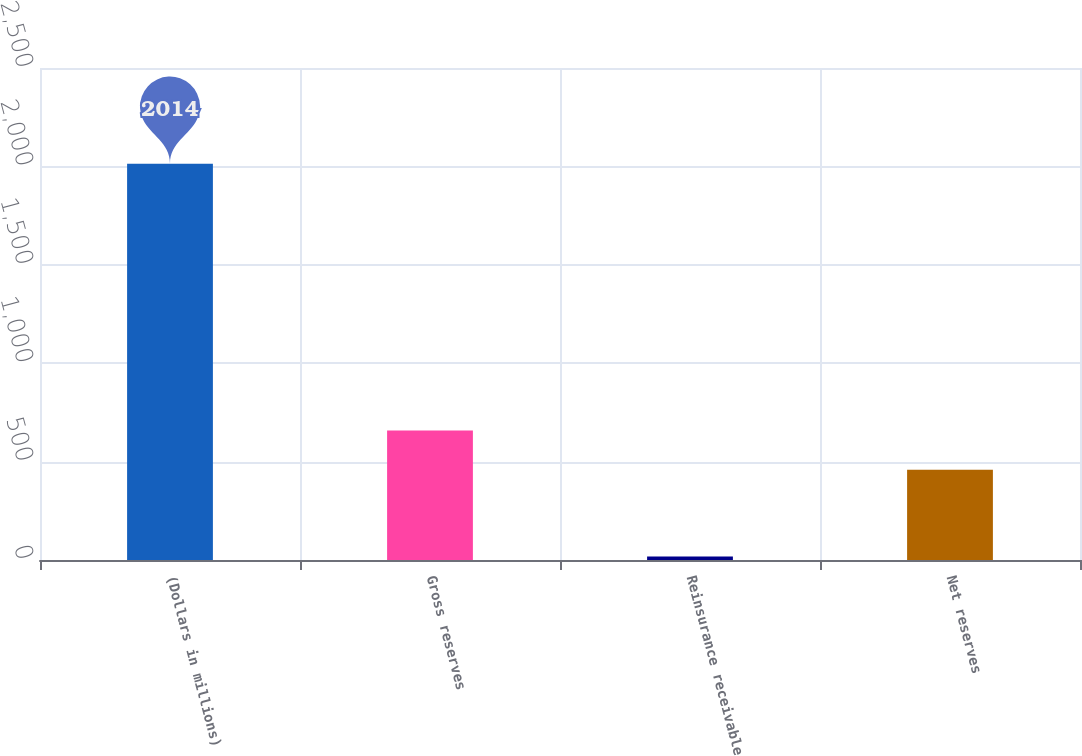Convert chart. <chart><loc_0><loc_0><loc_500><loc_500><bar_chart><fcel>(Dollars in millions)<fcel>Gross reserves<fcel>Reinsurance receivable<fcel>Net reserves<nl><fcel>2014<fcel>657.8<fcel>18<fcel>458.2<nl></chart> 